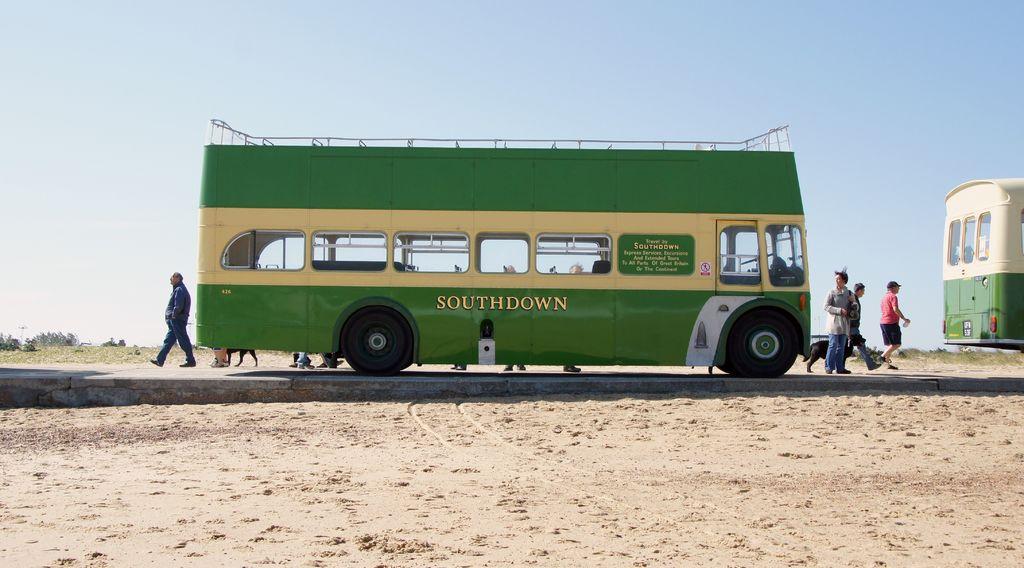What is the name of the company that owns this bus?
Offer a very short reply. Southdown. 